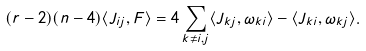<formula> <loc_0><loc_0><loc_500><loc_500>( r - 2 ) ( n - 4 ) \langle J _ { i j } , F \rangle = 4 \sum _ { k \neq i , j } \langle J _ { k j } , \omega _ { k i } \rangle - \langle J _ { k i } , \omega _ { k j } \rangle .</formula> 